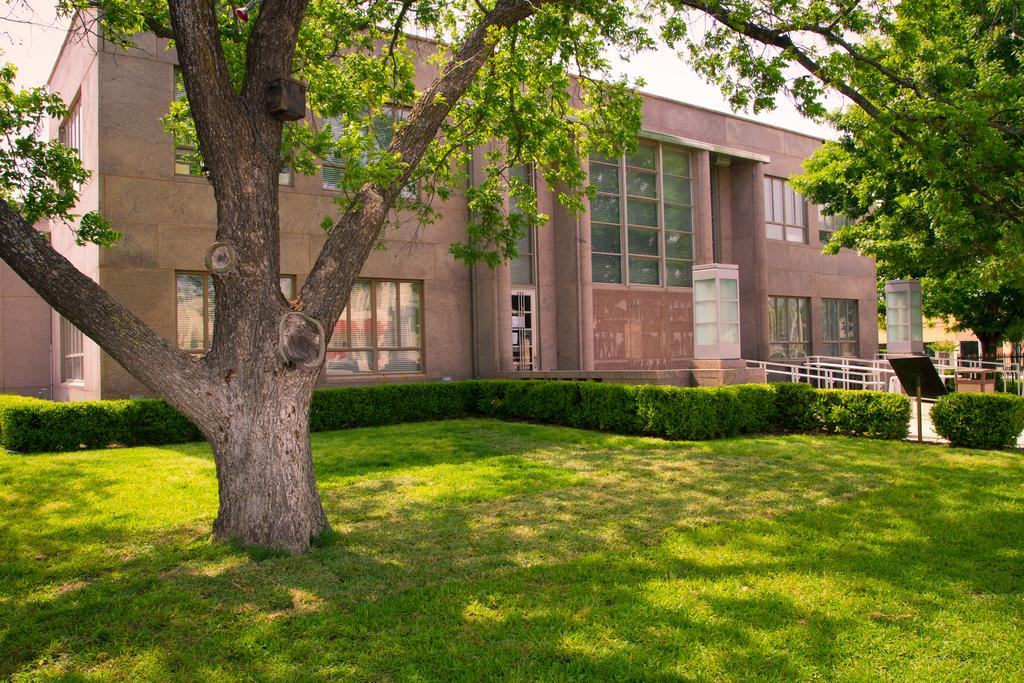What type of vegetation can be seen in the image? There are trees, plants, and grass in the image. What type of structure is present in the image? There is a building in the image. What type of barrier is visible in the image? There is a fence in the image. What else can be seen in the image besides the vegetation, building, and fence? There are other objects in the image. What is visible in the background of the image? The sky is visible in the background of the image. What type of silk is being offered by the belief system in the image? There is no silk or belief system present in the image. What type of belief system is associated with the offer of silk in the image? There is no offer of silk or belief system present in the image. 